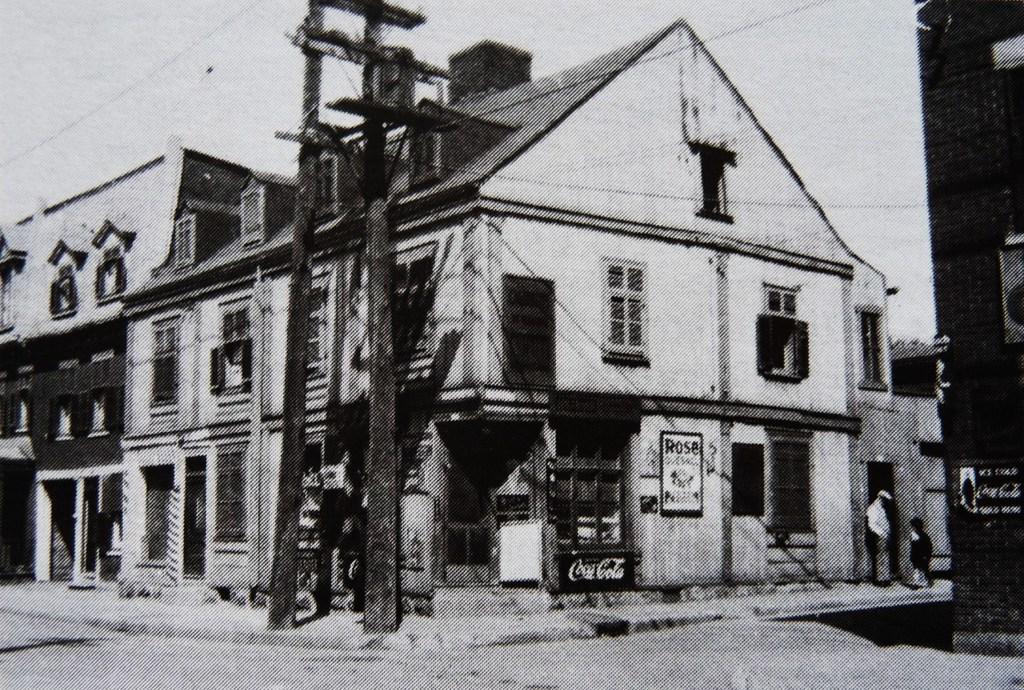Please provide a concise description of this image. In this image I can see there is a house in the middle. On the right side a man is standing and a child is also standing on the footpath there are poles in the middle, at the top it is the sky and this is the image in black and white color. 